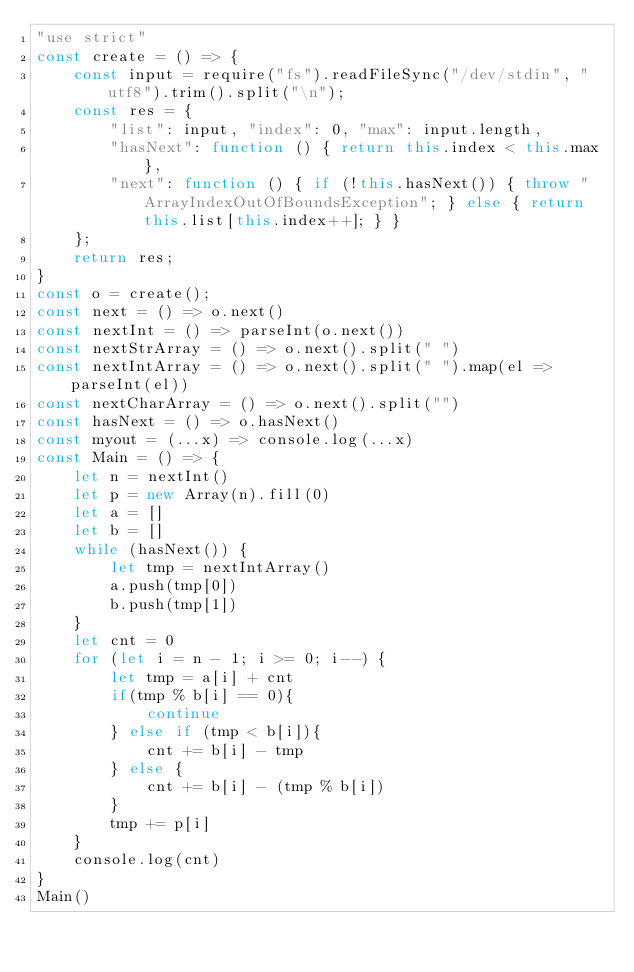Convert code to text. <code><loc_0><loc_0><loc_500><loc_500><_JavaScript_>"use strict"
const create = () => {
    const input = require("fs").readFileSync("/dev/stdin", "utf8").trim().split("\n");
    const res = {
        "list": input, "index": 0, "max": input.length,
        "hasNext": function () { return this.index < this.max },
        "next": function () { if (!this.hasNext()) { throw "ArrayIndexOutOfBoundsException"; } else { return this.list[this.index++]; } }
    };
    return res;
}
const o = create();
const next = () => o.next()
const nextInt = () => parseInt(o.next())
const nextStrArray = () => o.next().split(" ")
const nextIntArray = () => o.next().split(" ").map(el => parseInt(el))
const nextCharArray = () => o.next().split("")
const hasNext = () => o.hasNext()
const myout = (...x) => console.log(...x)
const Main = () => {
    let n = nextInt()
    let p = new Array(n).fill(0)
    let a = []
    let b = []
    while (hasNext()) {
        let tmp = nextIntArray()
        a.push(tmp[0])
        b.push(tmp[1])
    }
    let cnt = 0
    for (let i = n - 1; i >= 0; i--) {
        let tmp = a[i] + cnt
        if(tmp % b[i] == 0){
            continue
        } else if (tmp < b[i]){
            cnt += b[i] - tmp
        } else {
            cnt += b[i] - (tmp % b[i])
        }
        tmp += p[i]
    }
    console.log(cnt)
}
Main()

</code> 